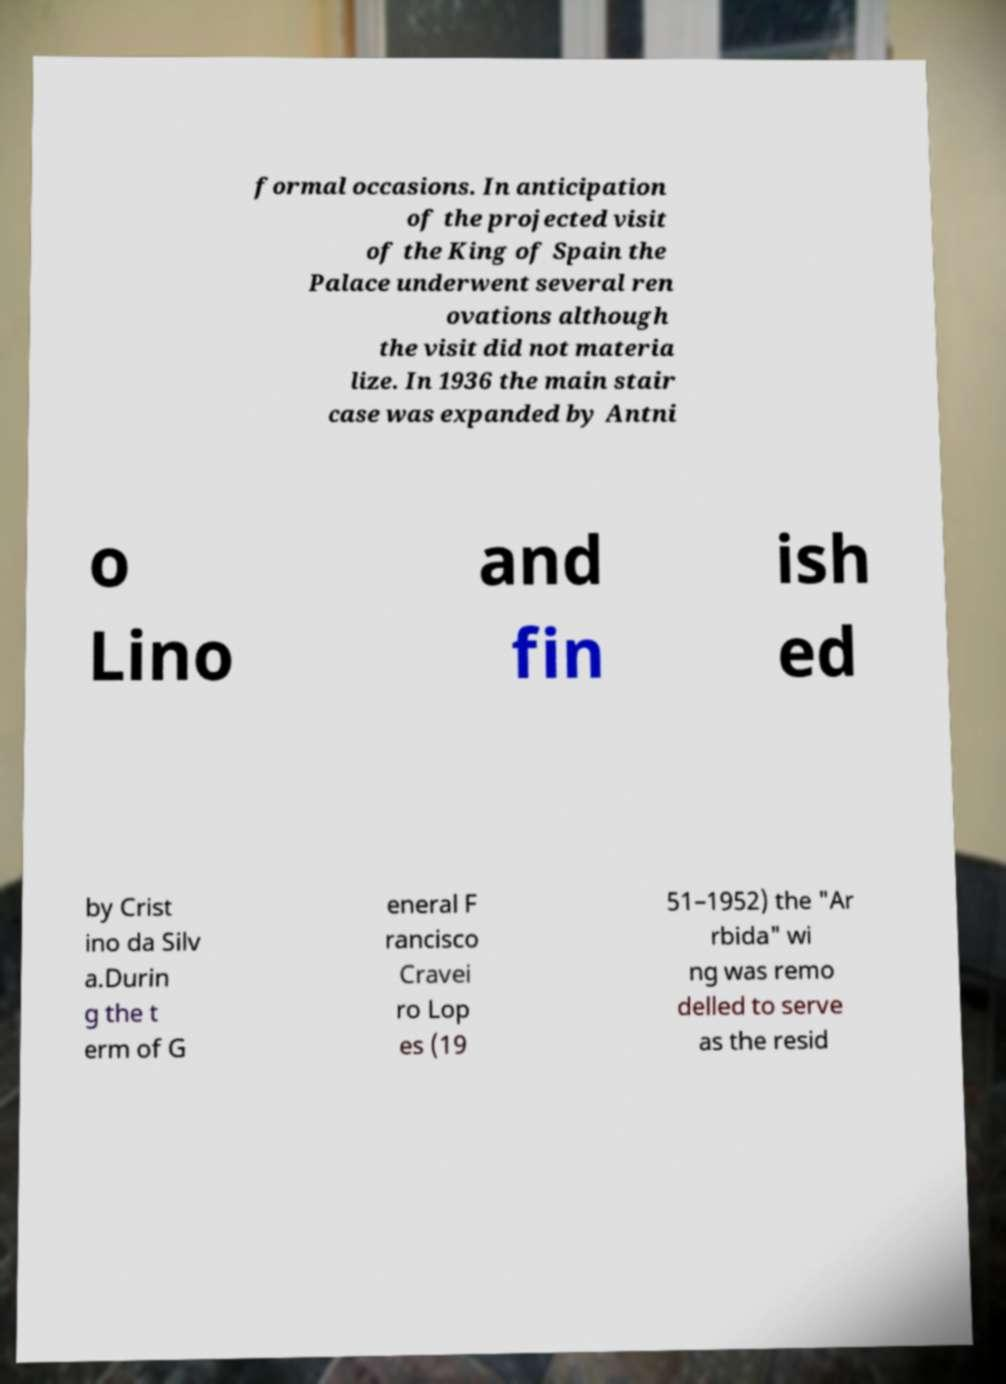Could you assist in decoding the text presented in this image and type it out clearly? formal occasions. In anticipation of the projected visit of the King of Spain the Palace underwent several ren ovations although the visit did not materia lize. In 1936 the main stair case was expanded by Antni o Lino and fin ish ed by Crist ino da Silv a.Durin g the t erm of G eneral F rancisco Cravei ro Lop es (19 51–1952) the "Ar rbida" wi ng was remo delled to serve as the resid 